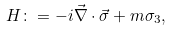<formula> <loc_0><loc_0><loc_500><loc_500>H \colon = - i \vec { \nabla } \cdot \vec { \sigma } + m \sigma _ { 3 } ,</formula> 